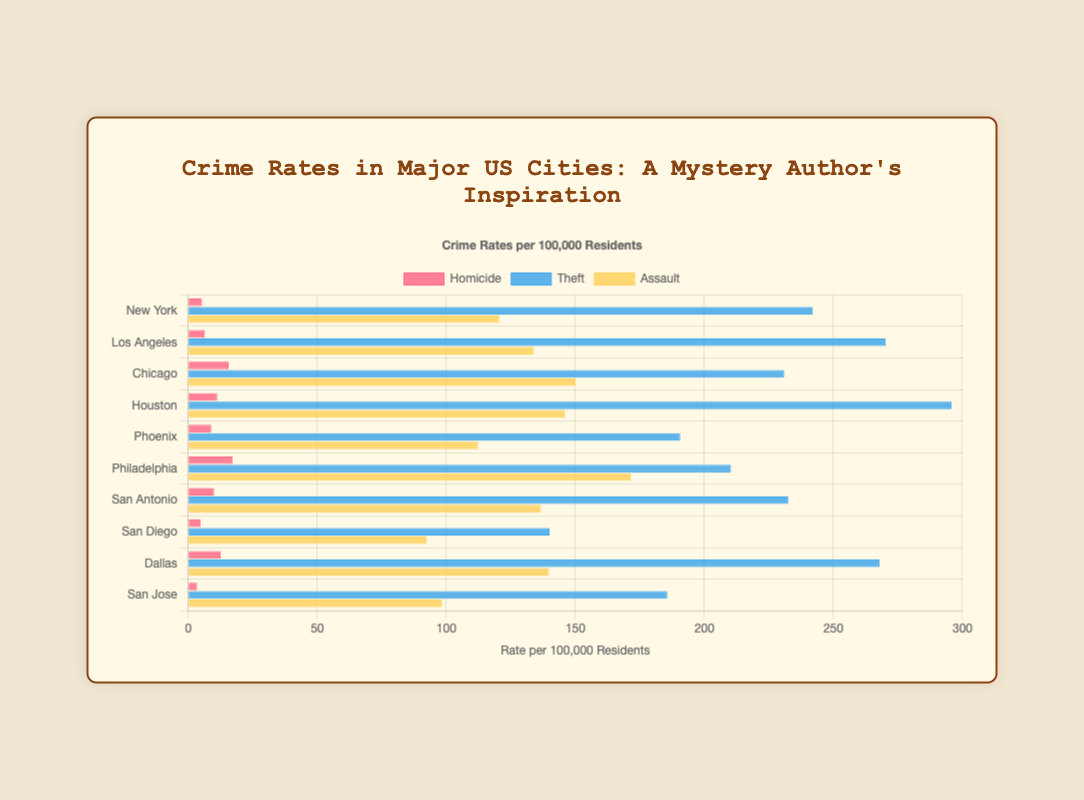Which city has the highest homicide rate? By observing the heights of the red bars representing 'Homicide' values, the one that reaches the highest corresponds to Philadelphia.
Answer: Philadelphia Which type of crime has the highest rate in Houston? Looking at Houston, the green bar representing 'Theft' is the longest compared to the red ('Homicide') and yellow ('Assault') bars.
Answer: Theft What is the sum of the homicide rates in Chicago and Philadelphia? Chicago's homicide rate is 15.6, and Philadelphia's is 17.1. Adding them together: 15.6 + 17.1 = 32.7
Answer: 32.7 Which city has higher theft rates, New York or San Antonio? Comparing the lengths of the blue bars for 'Theft' in both cities, New York’s bar is longer than San Antonio's.
Answer: New York What is the difference between the assault rates in Los Angeles and Dallas? Los Angeles has 133.9 for assault, and Dallas has 139.7. Subtracting these: 139.7 - 133.9 = 5.8
Answer: 5.8 What is the average theft rate across all cities? Sum all the theft rates: 242.0 + 270.3 + 230.9 + 295.7 + 190.6 + 210.3 + 232.5 + 140.0 + 267.8 + 185.6 = 2265.7. Divide by the number of cities (10): 2265.7 / 10 = 226.57
Answer: 226.57 Are the assault rates more varied in terms of bar length compared to homicide rates? Yes, the yellow bars (Assault) visually appear to have more noticeable differences in height across cities than the red bars (Homicide).
Answer: Yes Which city has the lowest crime rate in any category, and what is it? The lowest crime rate visually appears to be the red homicide bar in San Jose, which is the shortest amongst all lines, representing 3.4.
Answer: San Jose, 3.4 Which city shows higher rates for all crime types compared to San Diego? Comparing all three bars (red, blue, and yellow) for each city to San Diego, Los Angeles has higher values for 'Homicide', 'Theft', and 'Assault'.
Answer: Los Angeles 